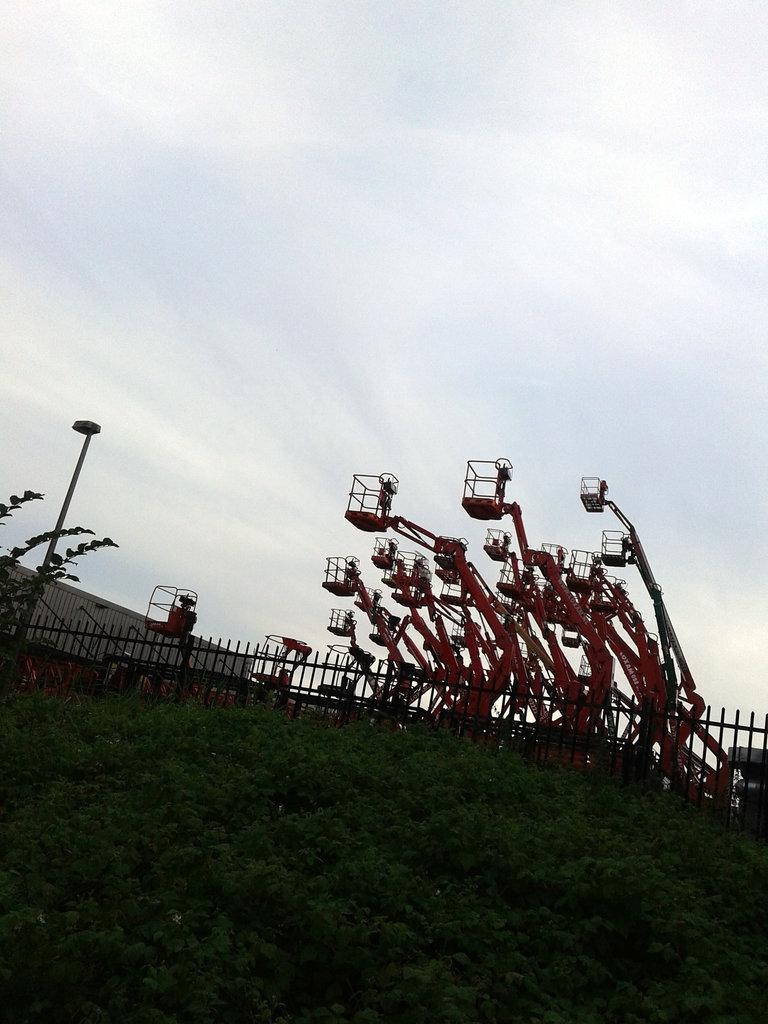What type of living organisms can be seen in the image? Plants can be seen in the image. What type of structure is present in the image? There is fencing in the image. What can be seen in the background of the image? Street light fitting vehicles can be seen in the background of the image. What is visible at the top of the image? The sky is clear and visible at the top of the image. What type of government is depicted in the image? There is no depiction of a government in the image; it features plants, fencing, street light fitting vehicles, and a clear sky. How many beds are visible in the image? There are no beds present in the image. 